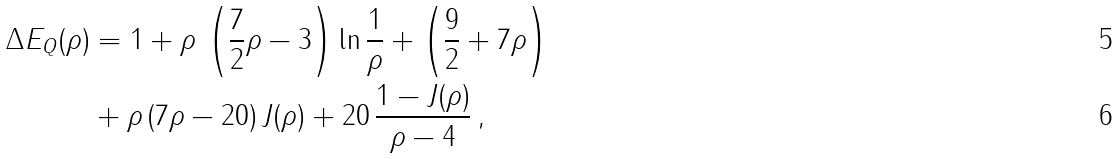Convert formula to latex. <formula><loc_0><loc_0><loc_500><loc_500>\Delta E _ { Q } ( \rho ) & = 1 + \rho \, \left ( \frac { 7 } { 2 } \rho - 3 \right ) \ln \frac { 1 } { \rho } + \left ( \frac { 9 } { 2 } + 7 \rho \right ) \\ & + \rho \, ( 7 \rho - 2 0 ) \, J ( \rho ) + 2 0 \, \frac { 1 - J ( \rho ) } { \rho - 4 } \, ,</formula> 